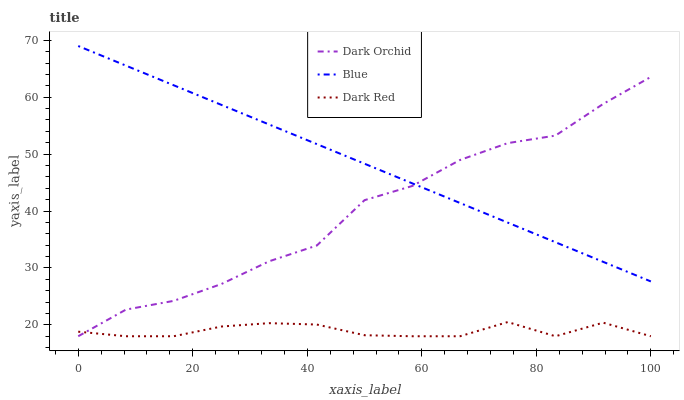Does Dark Red have the minimum area under the curve?
Answer yes or no. Yes. Does Blue have the maximum area under the curve?
Answer yes or no. Yes. Does Dark Orchid have the minimum area under the curve?
Answer yes or no. No. Does Dark Orchid have the maximum area under the curve?
Answer yes or no. No. Is Blue the smoothest?
Answer yes or no. Yes. Is Dark Orchid the roughest?
Answer yes or no. Yes. Is Dark Red the smoothest?
Answer yes or no. No. Is Dark Red the roughest?
Answer yes or no. No. Does Dark Red have the lowest value?
Answer yes or no. Yes. Does Blue have the highest value?
Answer yes or no. Yes. Does Dark Orchid have the highest value?
Answer yes or no. No. Is Dark Red less than Blue?
Answer yes or no. Yes. Is Blue greater than Dark Red?
Answer yes or no. Yes. Does Dark Orchid intersect Blue?
Answer yes or no. Yes. Is Dark Orchid less than Blue?
Answer yes or no. No. Is Dark Orchid greater than Blue?
Answer yes or no. No. Does Dark Red intersect Blue?
Answer yes or no. No. 